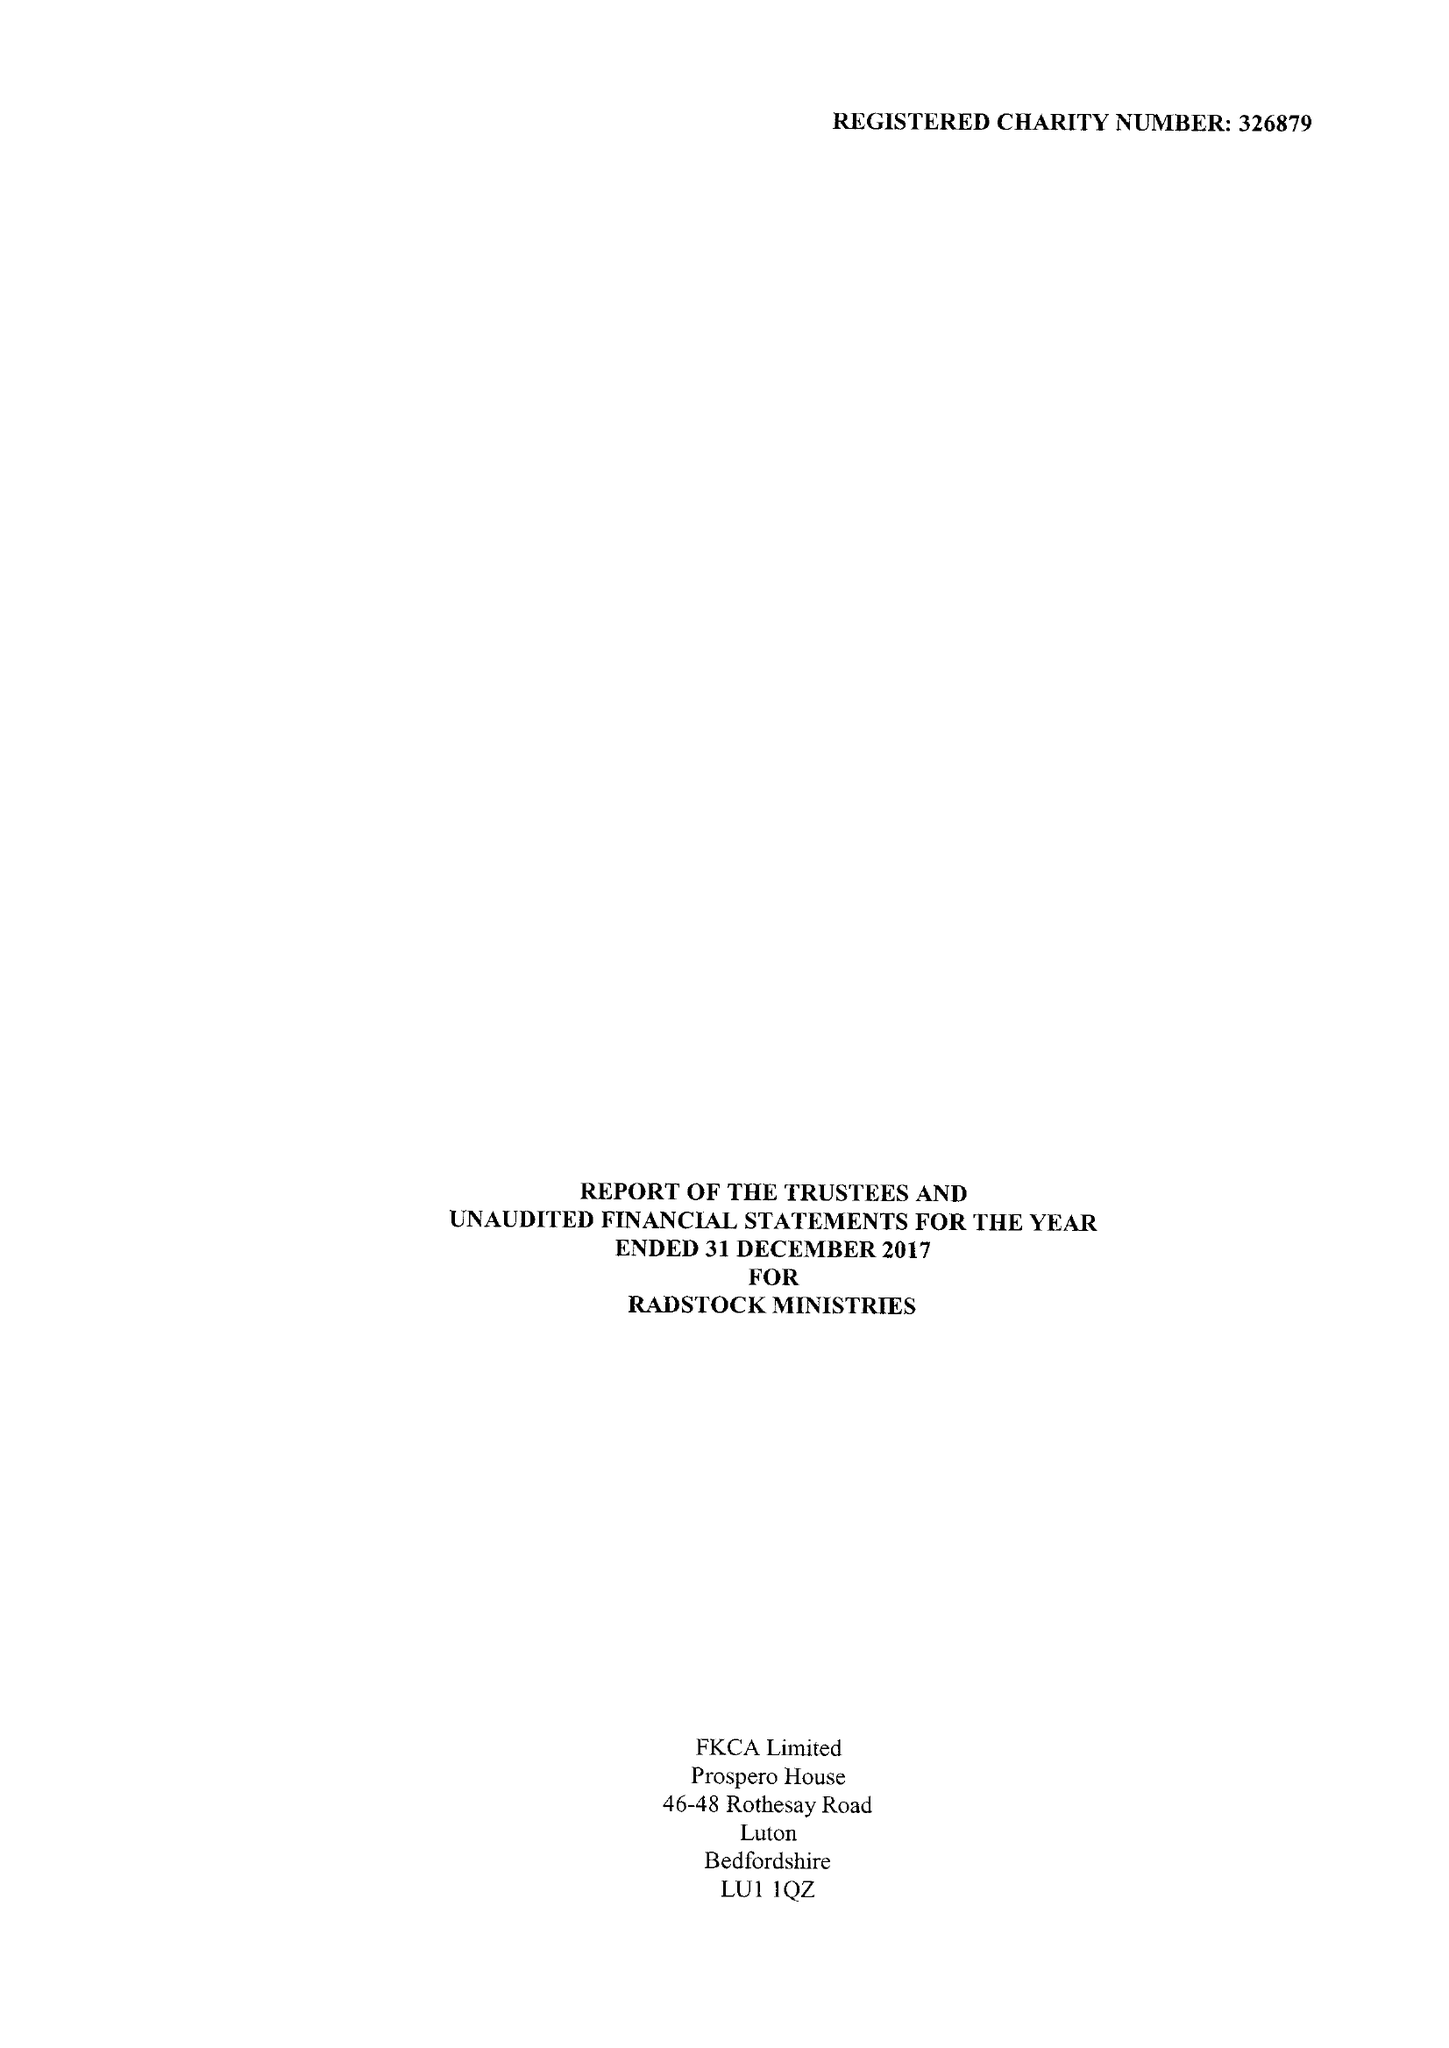What is the value for the report_date?
Answer the question using a single word or phrase. 2017-12-31 